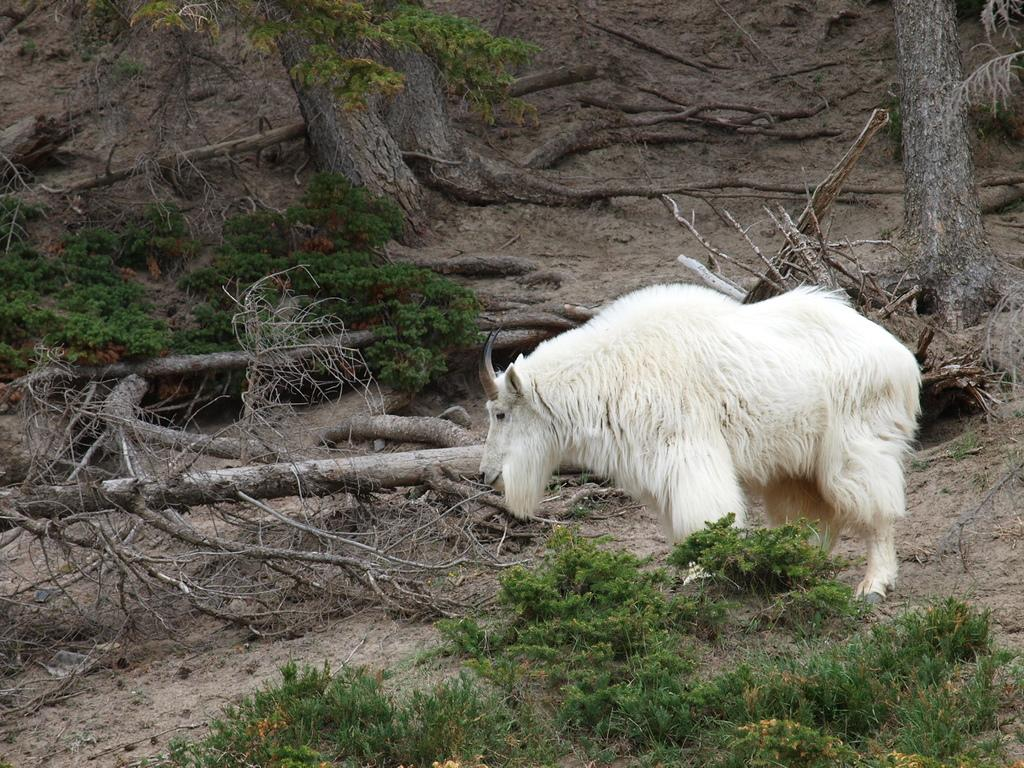What type of living creature is in the image? There is an animal in the image. What other natural elements can be seen in the image? There are plants and trees in the image. What is on the ground in the image? There are wooden logs on the ground in the image. What arithmetic problem is the animal solving in the image? There is no arithmetic problem present in the image, as it features an animal, plants, trees, and wooden logs. 